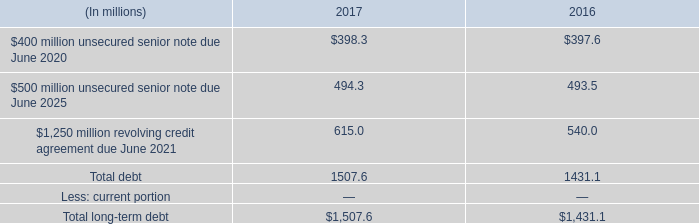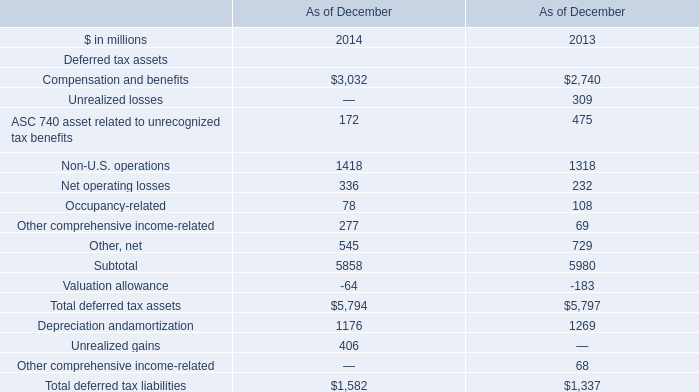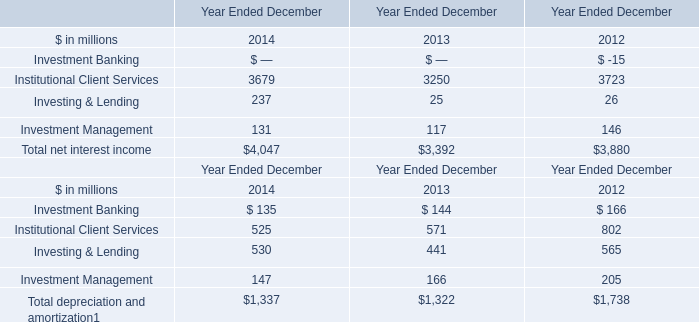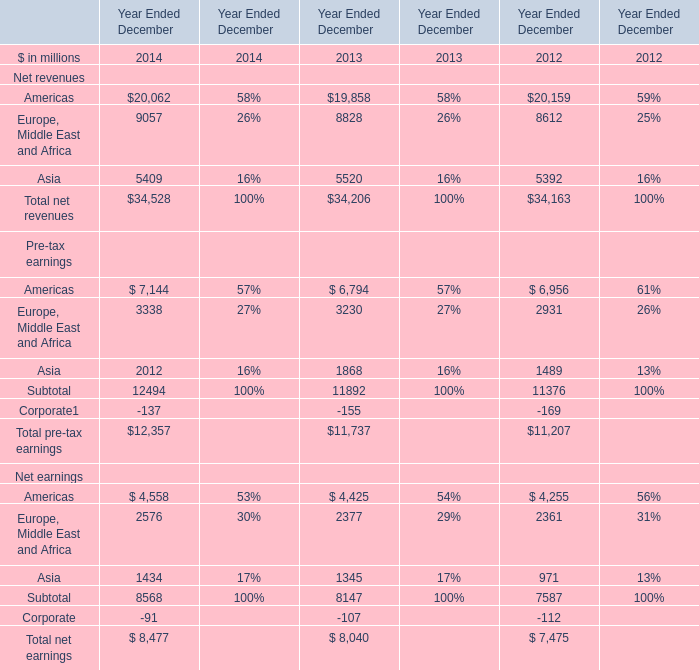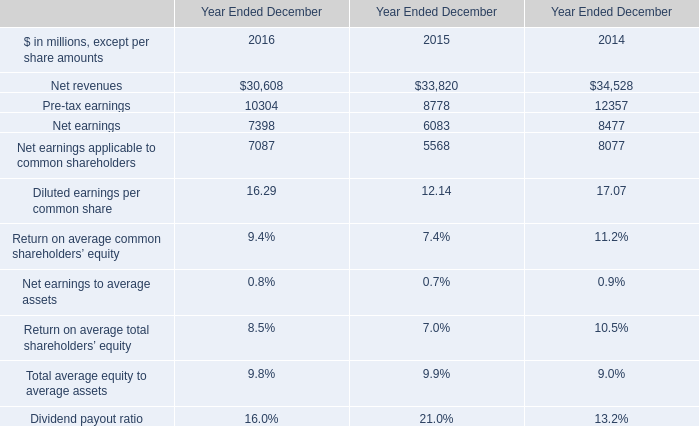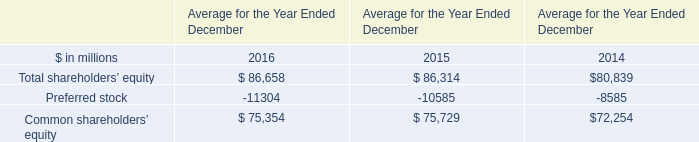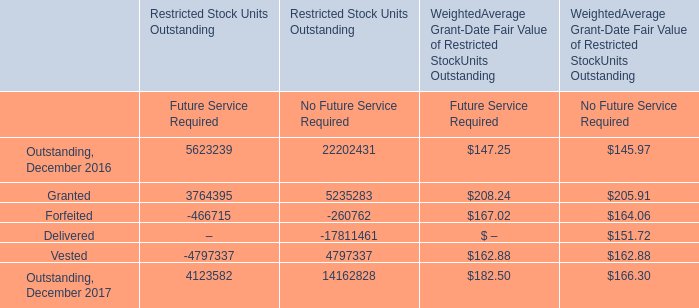What is the average amount of Vested of Restricted Stock Units Outstanding Future Service Required, and Preferred stock of Average for the Year Ended December 2015 ? 
Computations: ((4797337.0 + 10585.0) / 2)
Answer: 2403961.0. 